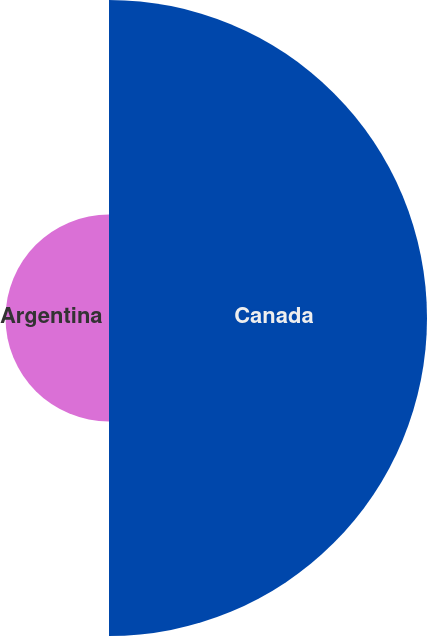Convert chart. <chart><loc_0><loc_0><loc_500><loc_500><pie_chart><fcel>Canada<fcel>Argentina<nl><fcel>75.45%<fcel>24.55%<nl></chart> 